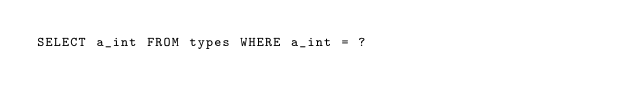Convert code to text. <code><loc_0><loc_0><loc_500><loc_500><_SQL_>SELECT a_int FROM types WHERE a_int = ?
</code> 